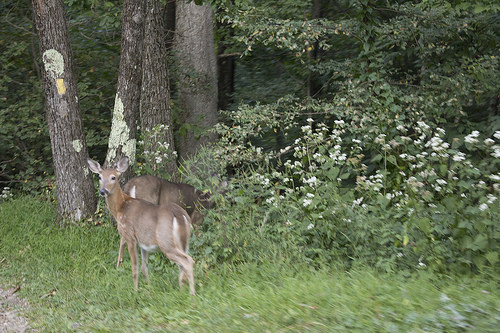<image>
Can you confirm if the deer is to the left of the tree? Yes. From this viewpoint, the deer is positioned to the left side relative to the tree. 